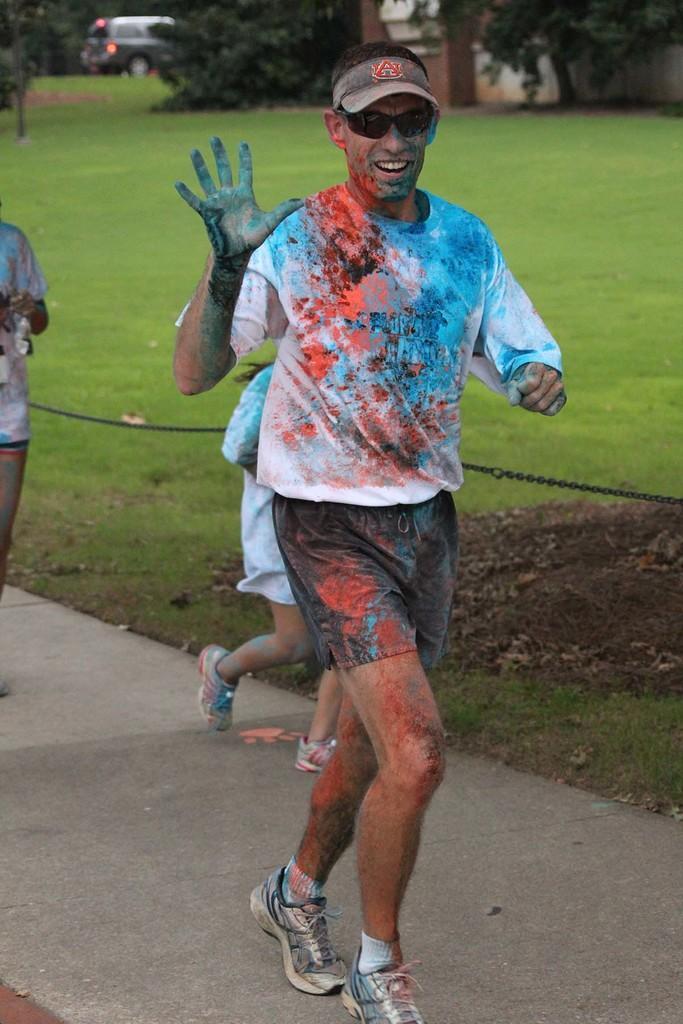How would you summarize this image in a sentence or two? This picture is clicked outside. In the foreground we can see the group of persons running on the ground. In the background there is a vehicle and we can see the green grass and the plants. 